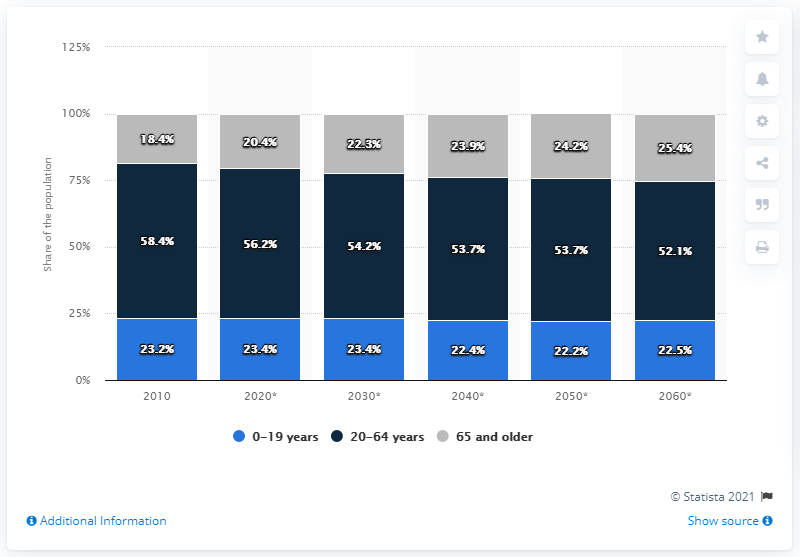Mention a couple of crucial points in this snapshot. By 2060, it is projected that 52.1% of Sweden's population will be between the ages of 20 and 64. 